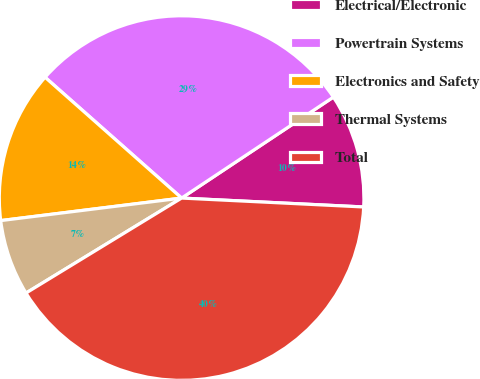Convert chart to OTSL. <chart><loc_0><loc_0><loc_500><loc_500><pie_chart><fcel>Electrical/Electronic<fcel>Powertrain Systems<fcel>Electronics and Safety<fcel>Thermal Systems<fcel>Total<nl><fcel>10.12%<fcel>29.13%<fcel>13.5%<fcel>6.75%<fcel>40.5%<nl></chart> 